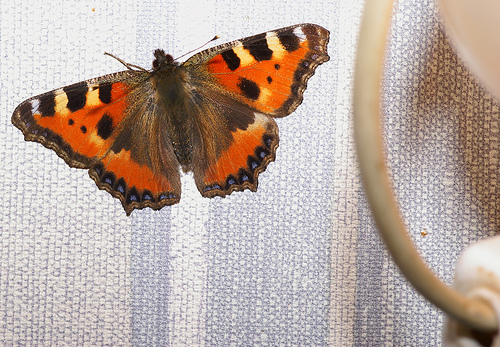<image>
Is there a moth to the left of the charger? Yes. From this viewpoint, the moth is positioned to the left side relative to the charger. 